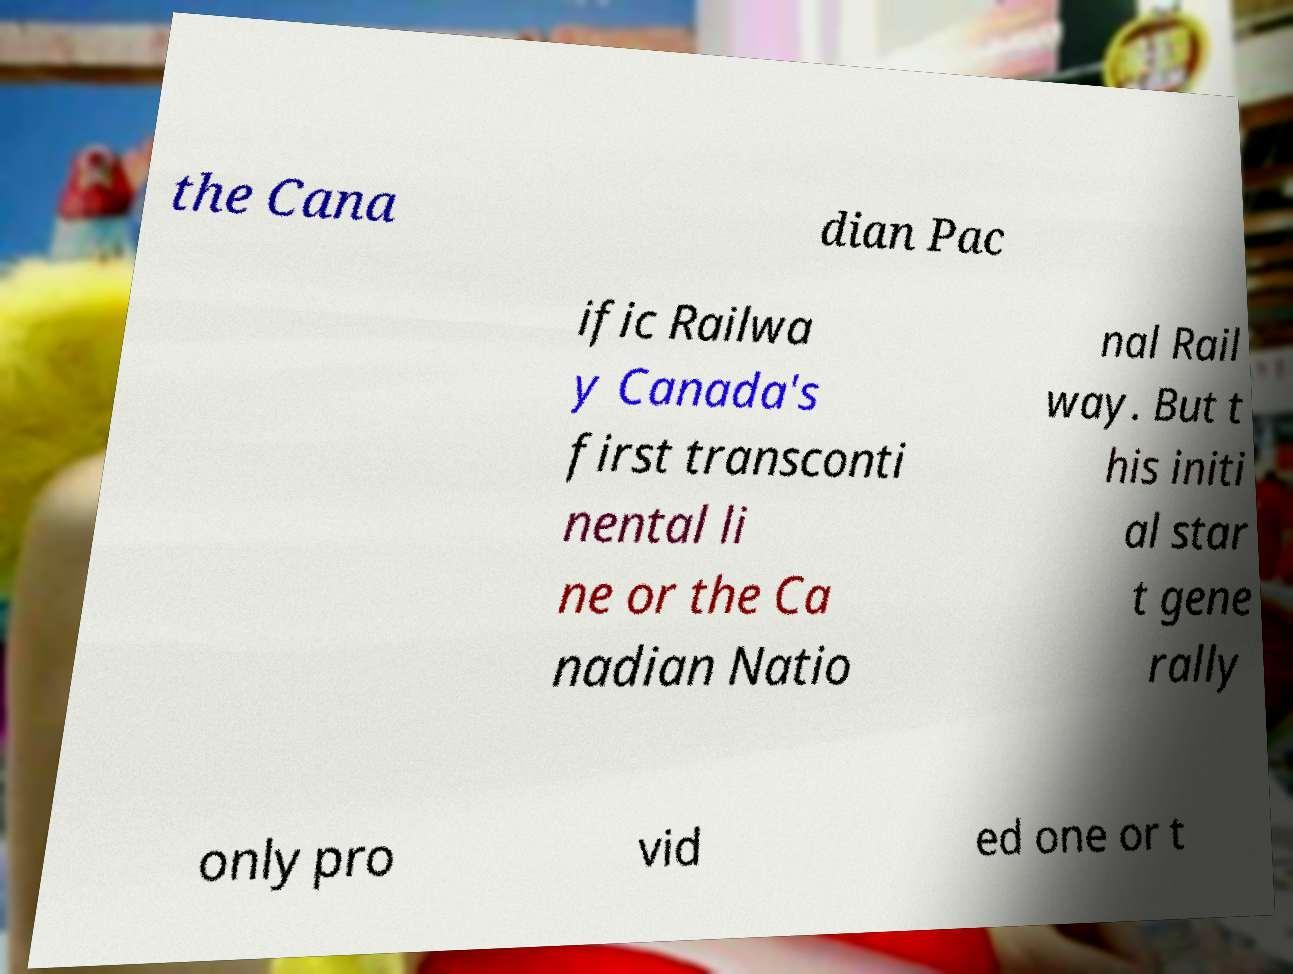I need the written content from this picture converted into text. Can you do that? the Cana dian Pac ific Railwa y Canada's first transconti nental li ne or the Ca nadian Natio nal Rail way. But t his initi al star t gene rally only pro vid ed one or t 